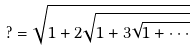<formula> <loc_0><loc_0><loc_500><loc_500>? = \sqrt { 1 + 2 \sqrt { 1 + 3 \sqrt { 1 + \cdot \cdot \cdot } } }</formula> 